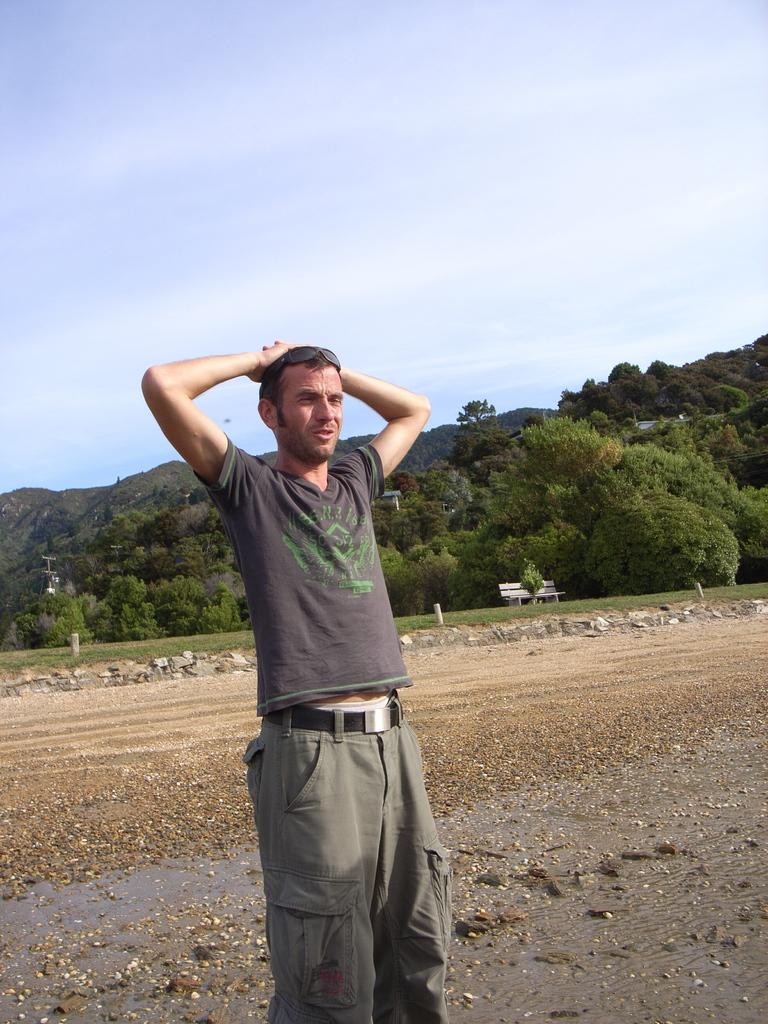Who or what is present in the image? There is a person in the image. What type of natural elements can be seen in the image? There are rocks and trees in the image. What type of structure is visible in the image? There is a house in the image. What part of the natural environment is visible in the image? The sky is visible in the image. Reasoning: Let's think step by step by step in order to produce the conversation. We start by identifying the main subject in the image, which is the person. Then, we expand the conversation to include other elements that are also visible, such as rocks, trees, the house, and the sky. Each question is designed to elicit a specific detail about the image that is known from the provided facts. Absurd Question/Answer: How many dogs are present in the image? There are no dogs present in the image. What type of motion is the person performing in the image? The image does not show any motion or action of the person, so it cannot be determined from the image. 